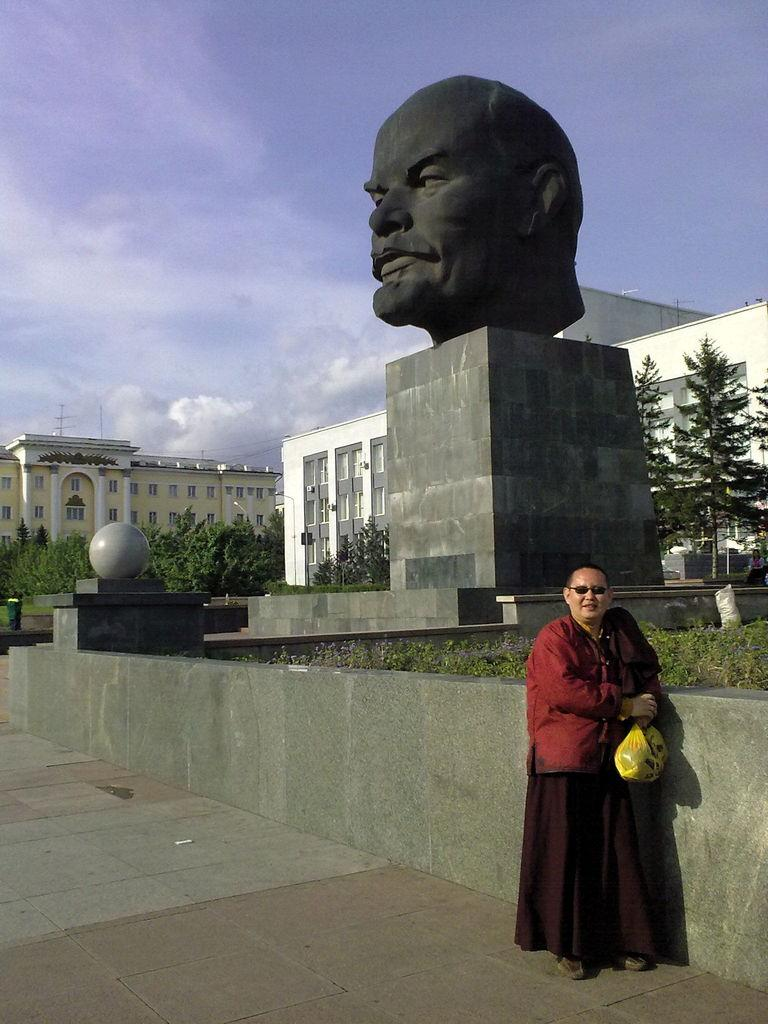What is the main subject of the image? There is a sculptor in the image. What is the person holding in the image? There is a person holding an object in the image. What type of structures can be seen in the image? There are buildings in the image. What type of vegetation is present in the image? There are trees in the image. What part of the natural environment is visible in the image? There is sky visible in the image. What type of note is the person playing on the piano in the image? There is no piano or note present in the image; it features a sculptor and a person holding an object. How many kittens are sitting on the person's lap in the image? There are no kittens present in the image. 